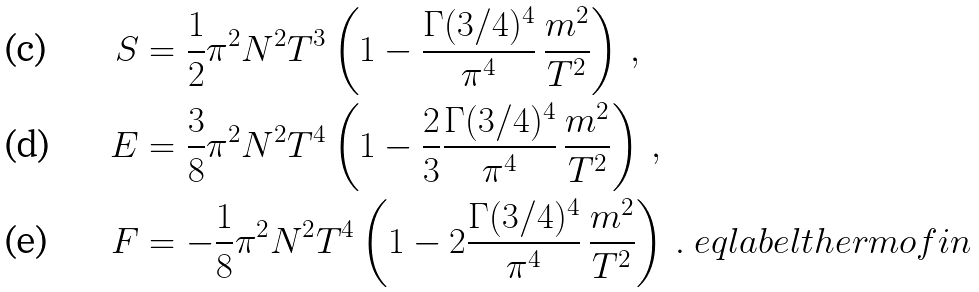Convert formula to latex. <formula><loc_0><loc_0><loc_500><loc_500>S & = \frac { 1 } { 2 } \pi ^ { 2 } N ^ { 2 } T ^ { 3 } \left ( 1 - \frac { \Gamma ( 3 / 4 ) ^ { 4 } } { \pi ^ { 4 } } \, \frac { m ^ { 2 } } { T ^ { 2 } } \right ) \, , \\ E & = \frac { 3 } { 8 } \pi ^ { 2 } N ^ { 2 } T ^ { 4 } \left ( 1 - \frac { 2 } { 3 } \frac { \Gamma ( 3 / 4 ) ^ { 4 } } { \pi ^ { 4 } } \, \frac { m ^ { 2 } } { T ^ { 2 } } \right ) \, , \\ F & = - \frac { 1 } { 8 } \pi ^ { 2 } N ^ { 2 } T ^ { 4 } \left ( 1 - 2 \frac { \Gamma ( 3 / 4 ) ^ { 4 } } { \pi ^ { 4 } } \, \frac { m ^ { 2 } } { T ^ { 2 } } \right ) \, . \ e q l a b e l { t h e r m o f i n }</formula> 